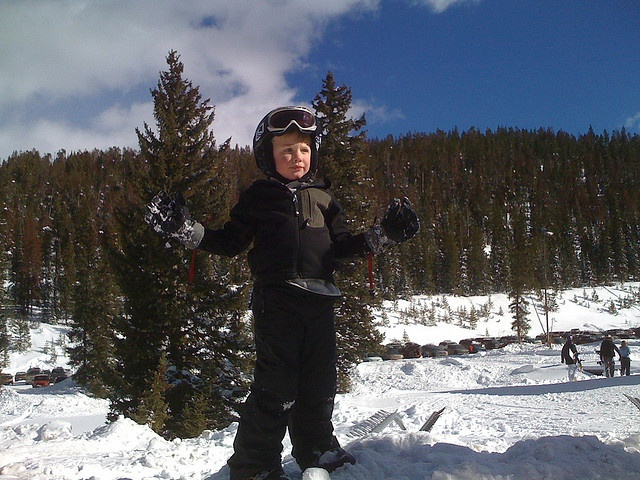Describe the objects in this image and their specific colors. I can see people in gray, black, and maroon tones, people in gray, black, and darkgray tones, people in gray, black, and darkgray tones, people in gray, black, and blue tones, and car in gray, black, and darkgray tones in this image. 